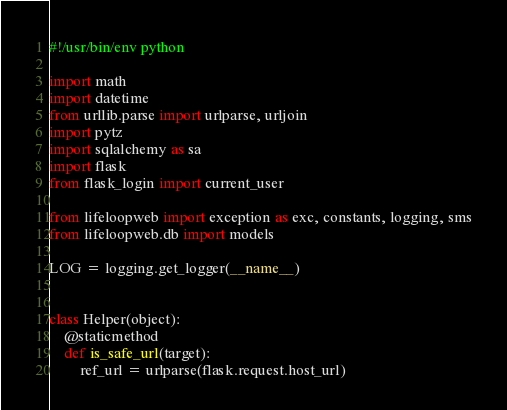<code> <loc_0><loc_0><loc_500><loc_500><_Python_>#!/usr/bin/env python

import math
import datetime
from urllib.parse import urlparse, urljoin
import pytz
import sqlalchemy as sa
import flask
from flask_login import current_user

from lifeloopweb import exception as exc, constants, logging, sms
from lifeloopweb.db import models

LOG = logging.get_logger(__name__)


class Helper(object):
    @staticmethod
    def is_safe_url(target):
        ref_url = urlparse(flask.request.host_url)</code> 